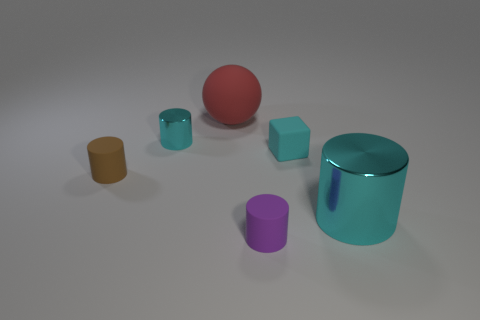What number of purple cylinders are the same size as the brown cylinder?
Keep it short and to the point. 1. What number of small purple cylinders are in front of the red object behind the small brown matte cylinder?
Provide a short and direct response. 1. Is the tiny cylinder behind the small brown matte object made of the same material as the brown cylinder?
Ensure brevity in your answer.  No. Do the cyan object that is in front of the brown rubber cylinder and the cyan cylinder to the left of the big shiny thing have the same material?
Provide a succinct answer. Yes. Is the number of cyan metal things that are to the left of the ball greater than the number of green cubes?
Your response must be concise. Yes. There is a cylinder in front of the cyan cylinder to the right of the purple thing; what color is it?
Keep it short and to the point. Purple. The cyan matte thing that is the same size as the brown rubber object is what shape?
Provide a short and direct response. Cube. There is another metal object that is the same color as the big metallic object; what is its shape?
Provide a succinct answer. Cylinder. Are there an equal number of matte cylinders right of the matte cube and large cyan metallic blocks?
Provide a short and direct response. Yes. There is a large object that is in front of the metal cylinder behind the metal object to the right of the tiny metal cylinder; what is its material?
Offer a very short reply. Metal. 